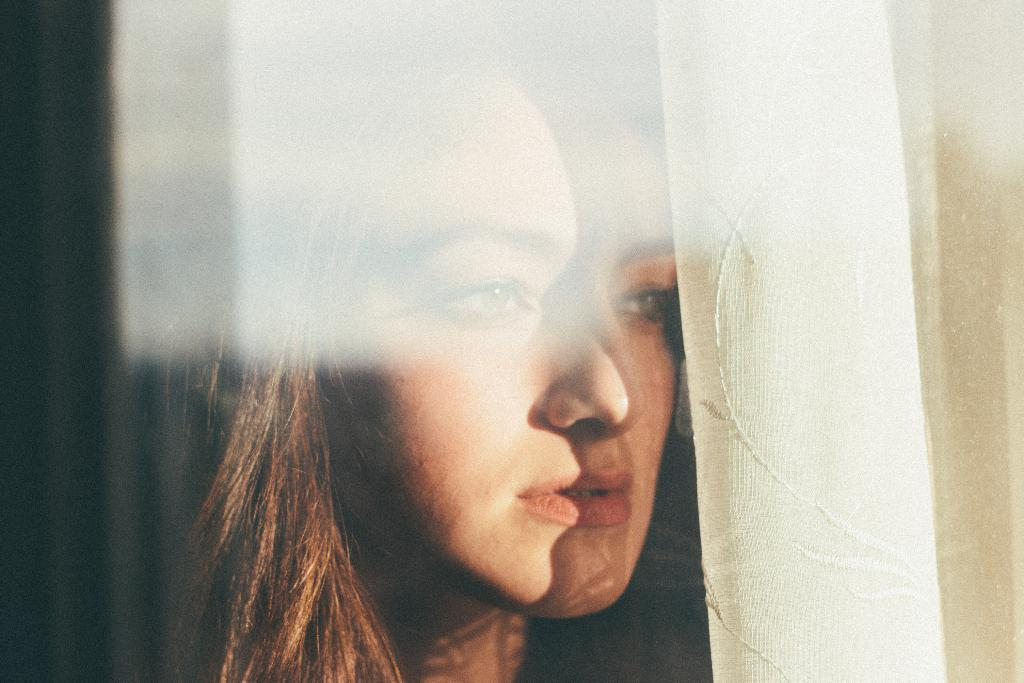Who is present in the image? There is a woman in the image. What can be seen on the right side of the image? There is a white curtain on the right side of the image. How is the woman's face illuminated in the image? Sunlight is visible on the woman's face. What object is in front of the woman? There is a glass in front of the woman. Is there a hill visible in the background of the image? There is no hill visible in the background of the image. What type of cart is being used by the woman in the image? There is no cart present in the image. 